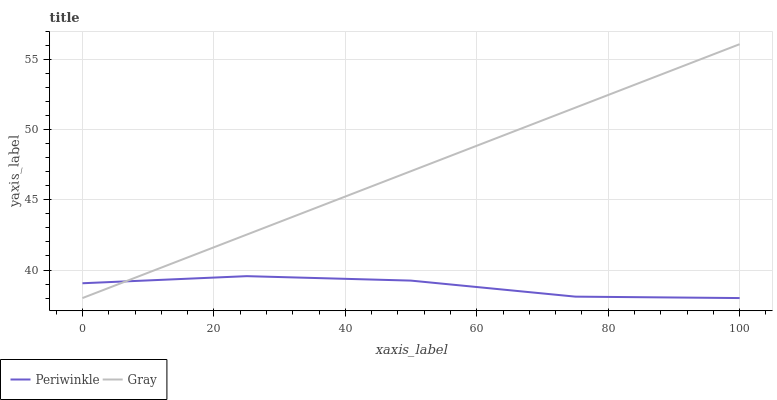Does Periwinkle have the minimum area under the curve?
Answer yes or no. Yes. Does Gray have the maximum area under the curve?
Answer yes or no. Yes. Does Periwinkle have the maximum area under the curve?
Answer yes or no. No. Is Gray the smoothest?
Answer yes or no. Yes. Is Periwinkle the roughest?
Answer yes or no. Yes. Is Periwinkle the smoothest?
Answer yes or no. No. Does Gray have the lowest value?
Answer yes or no. Yes. Does Gray have the highest value?
Answer yes or no. Yes. Does Periwinkle have the highest value?
Answer yes or no. No. Does Periwinkle intersect Gray?
Answer yes or no. Yes. Is Periwinkle less than Gray?
Answer yes or no. No. Is Periwinkle greater than Gray?
Answer yes or no. No. 